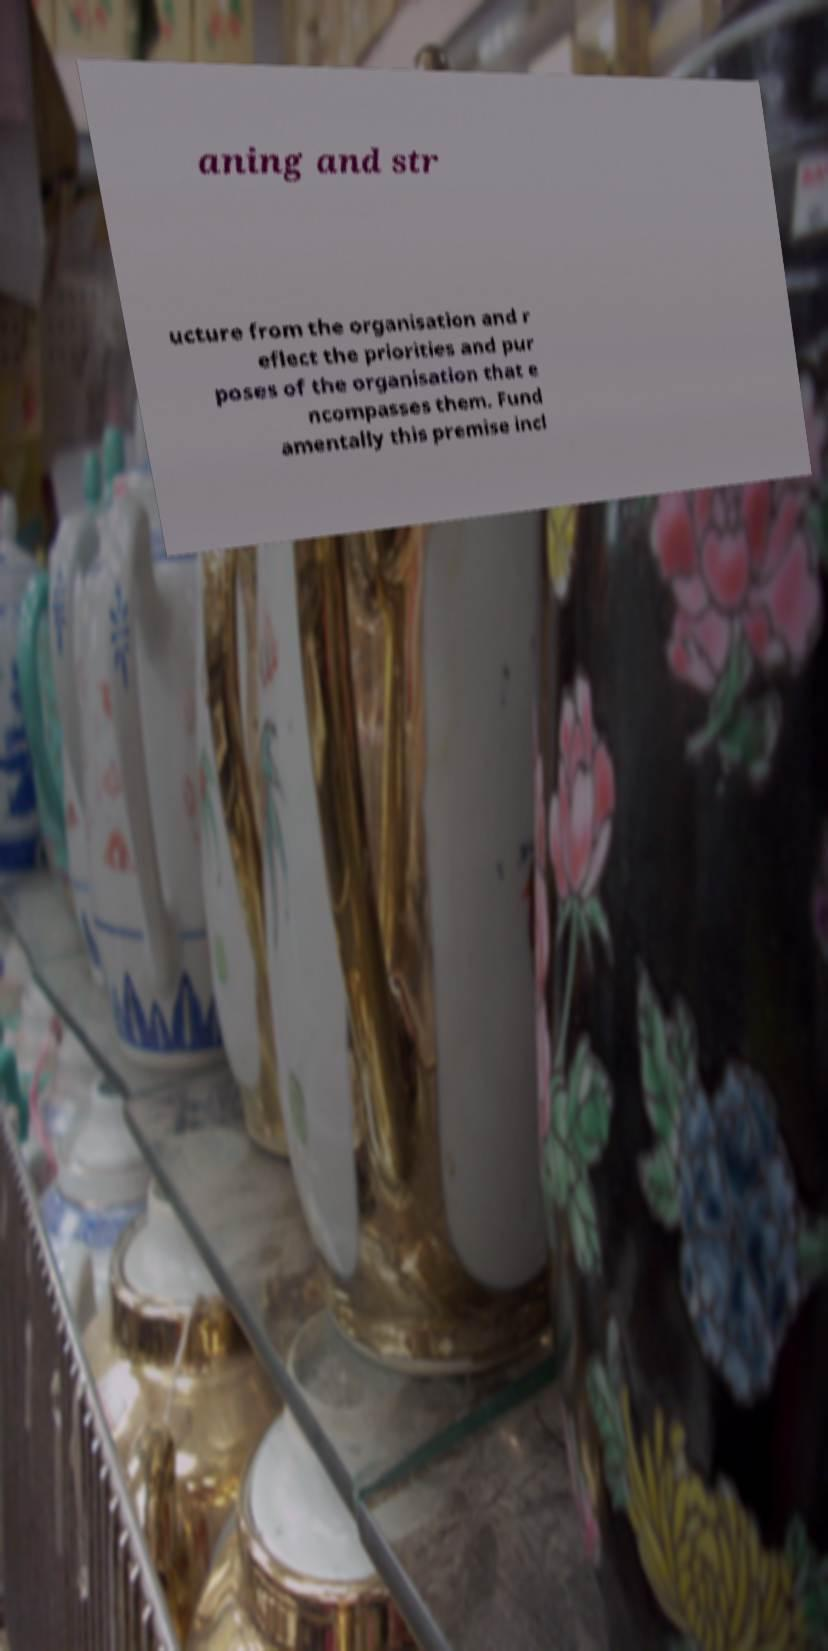Can you accurately transcribe the text from the provided image for me? aning and str ucture from the organisation and r eflect the priorities and pur poses of the organisation that e ncompasses them. Fund amentally this premise incl 